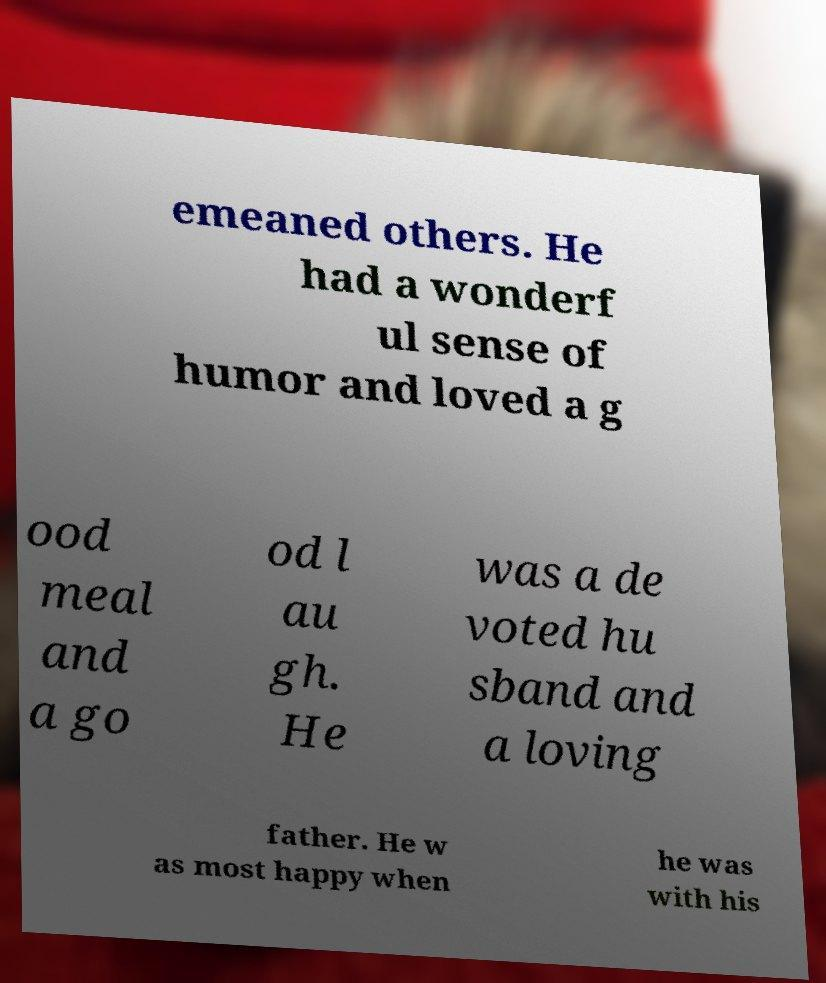Could you extract and type out the text from this image? emeaned others. He had a wonderf ul sense of humor and loved a g ood meal and a go od l au gh. He was a de voted hu sband and a loving father. He w as most happy when he was with his 